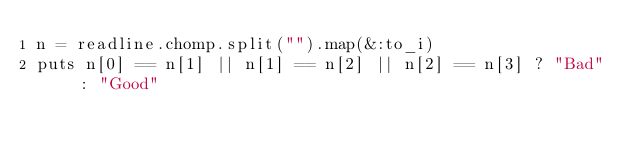<code> <loc_0><loc_0><loc_500><loc_500><_Ruby_>n = readline.chomp.split("").map(&:to_i)
puts n[0] == n[1] || n[1] == n[2] || n[2] == n[3] ? "Bad" : "Good"</code> 